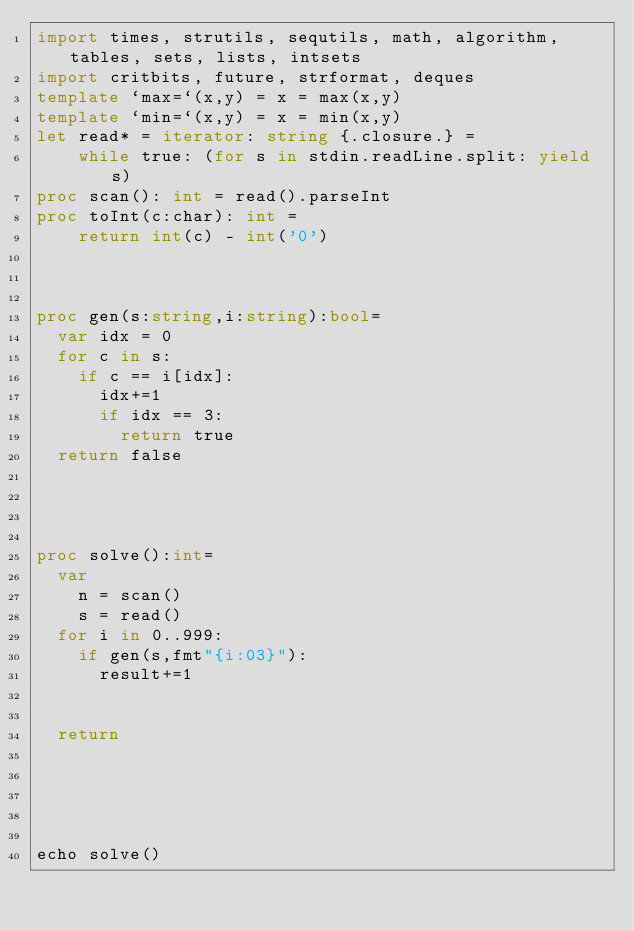<code> <loc_0><loc_0><loc_500><loc_500><_Nim_>import times, strutils, sequtils, math, algorithm, tables, sets, lists, intsets
import critbits, future, strformat, deques
template `max=`(x,y) = x = max(x,y)
template `min=`(x,y) = x = min(x,y)
let read* = iterator: string {.closure.} =
    while true: (for s in stdin.readLine.split: yield s)
proc scan(): int = read().parseInt
proc toInt(c:char): int =
    return int(c) - int('0')



proc gen(s:string,i:string):bool=
  var idx = 0
  for c in s:
    if c == i[idx]:
      idx+=1
      if idx == 3:
        return true
  return false
    



proc solve():int=
  var
    n = scan()
    s = read()
  for i in 0..999:
    if gen(s,fmt"{i:03}"):
      result+=1


  return
  
    

    
  
echo solve()</code> 